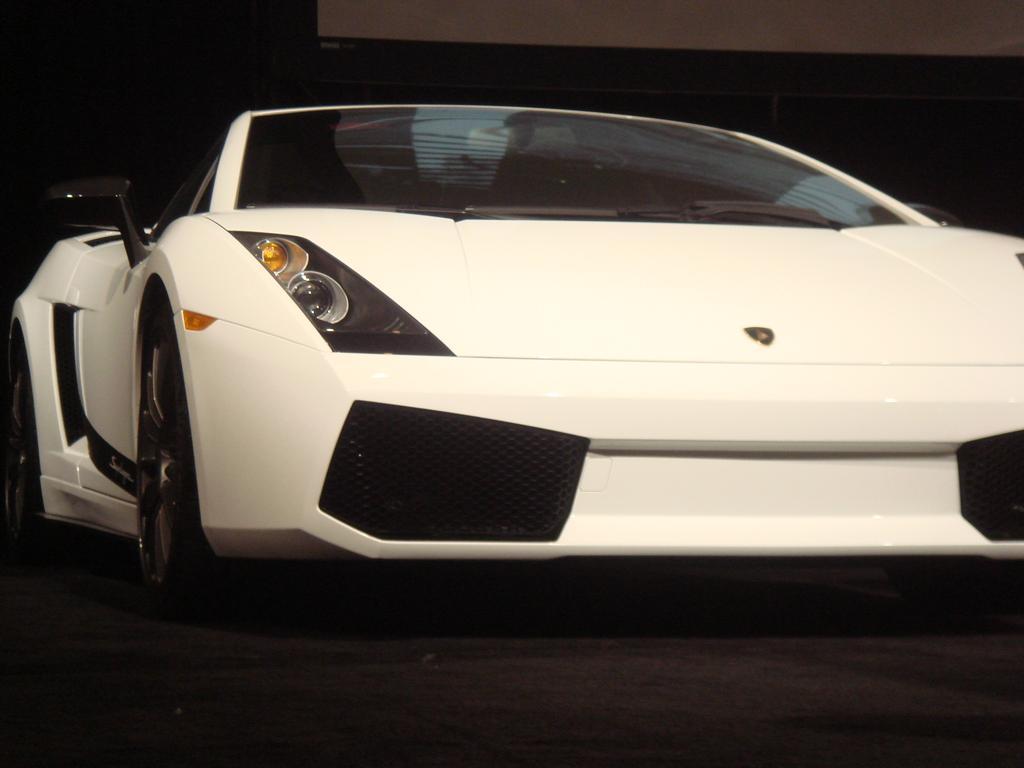In one or two sentences, can you explain what this image depicts? This picture shows a white sports car and we see a black background. 